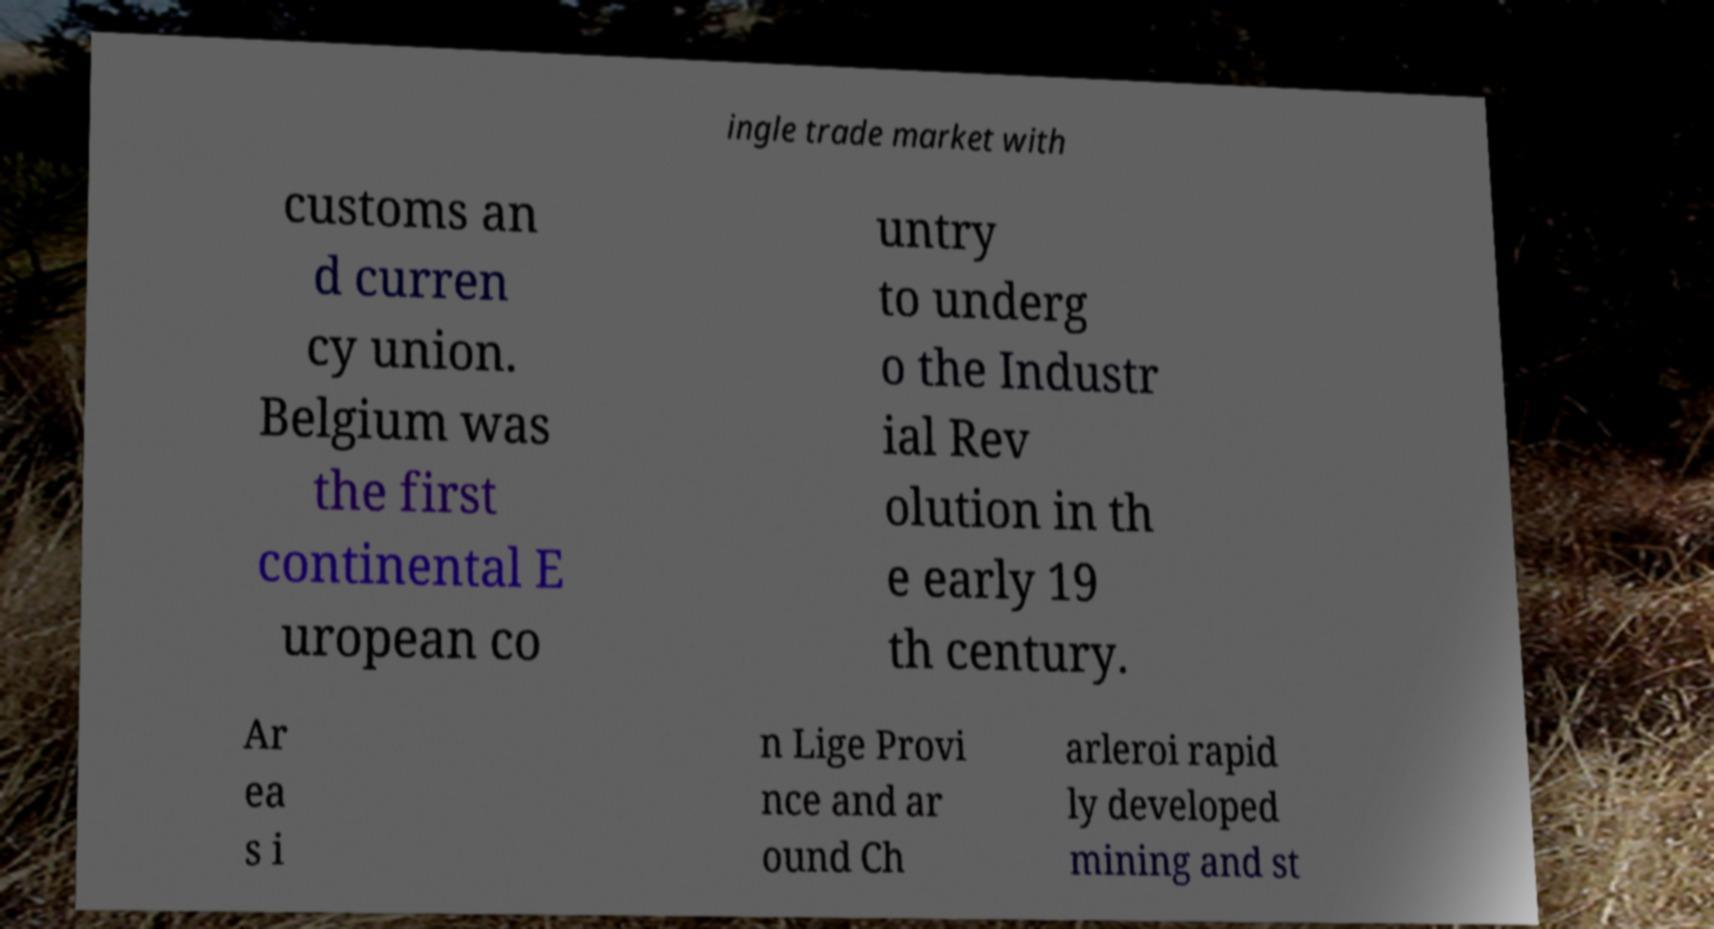What messages or text are displayed in this image? I need them in a readable, typed format. ingle trade market with customs an d curren cy union. Belgium was the first continental E uropean co untry to underg o the Industr ial Rev olution in th e early 19 th century. Ar ea s i n Lige Provi nce and ar ound Ch arleroi rapid ly developed mining and st 